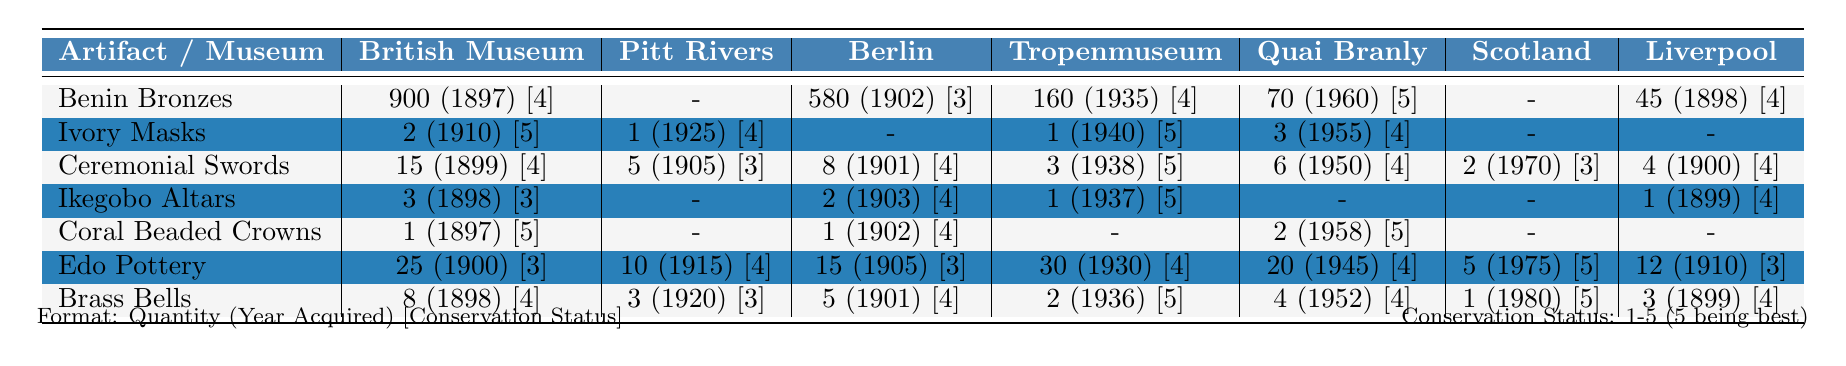What is the total number of Benin Bronzes in all listed museums? The table shows the quantities of Benin Bronzes in each museum: British Museum (900), Pitt Rivers (2), Ethnological Museum of Berlin (15), Tropenmuseum (3), Musée du quai Branly (1), National Museum of Scotland (25), and World Museum Liverpool (8). Adding these gives: 900 + 2 + 15 + 3 + 1 + 25 + 8 = 954.
Answer: 954 Which museum has the highest number of Edo Pottery artifacts? According to the table, the quantities of Edo Pottery are: British Museum (25), Pitt Rivers (10), Ethnological Museum of Berlin (15), Tropenmuseum (30), Musée du quai Branly (20), National Museum of Scotland (5), and World Museum Liverpool (12). The highest amount is in the Tropenmuseum with 30 artifacts.
Answer: Tropenmuseum Is there a museum with no Ivory Masks? The table shows that the Ethnological Museum of Berlin and the National Museum of Scotland have no Ivory Masks listed (0). Hence, the statement is true.
Answer: Yes What is the average conservation status for the Ceremonial Swords across all museums? The conservation statuses for Ceremonial Swords are: British Museum (4), Pitt Rivers (3), Ethnological Museum of Berlin (4), Tropenmuseum (5), Musée du quai Branly (4), National Museum of Scotland (3), and World Museum Liverpool (4). The average is calculated by summing these values: 4 + 3 + 4 + 5 + 4 + 3 + 4 = 27 and dividing by the number of entries (7), which is 27/7 = 3.86, rounded to two decimal places.
Answer: 3.86 Which artifact has the lowest acquisition year in the British Museum? Looking at the British Museum's acquisition years for the artifacts: Benin Bronzes (1897), Ivory Masks (1910), Ceremonial Swords (1899), Ikegobo Altars (1898), Coral Beaded Crowns (1897), Edo Pottery (1900), Brass Bells (1898). The lowest year is 1897, which belongs to both Benin Bronzes and Coral Beaded Crowns.
Answer: 1897 How many more Coral Beaded Crowns does the British Museum have compared to the National Museum of Scotland? The British Museum has 1 Coral Beaded Crown, while the National Museum of Scotland has 0. The difference is 1 - 0 = 1.
Answer: 1 Do all museums have at least one artifact from Edo culture? From the table, the Pitt Rivers and Musée du quai Branly do not have any artifacts listed, specifically 0 of none listed. Therefore, the statement is false.
Answer: No What is the total quantity of artifacts held by the Tropenmuseum? From the table, the quantities for Tropenmuseum are: Benin Bronzes (160), Ivory Masks (1), Ceremonial Swords (3), Ikegobo Altars (1), Coral Beaded Crowns (0), Edo Pottery (30), and Brass Bells (2). Adding these gives: 160 + 1 + 3 + 1 + 0 + 30 + 2 = 197.
Answer: 197 Which artifact has the highest conservation status rating in the Ethnological Museum of Berlin? The table shows that for the Ethnological Museum of Berlin, the conservation statuses are: Benin Bronzes (3), Ivory Masks (0), Ceremonial Swords (4), Ikegobo Altars (4), Coral Beaded Crowns (4), Edo Pottery (3), and Brass Bells (4). The highest is 4 for multiple artifacts: Ceremonial Swords, Ikegobo Altars, Coral Beaded Crowns, and Brass Bells.
Answer: Ceremonial Swords, Ikegobo Altars, Coral Beaded Crowns, Brass Bells 